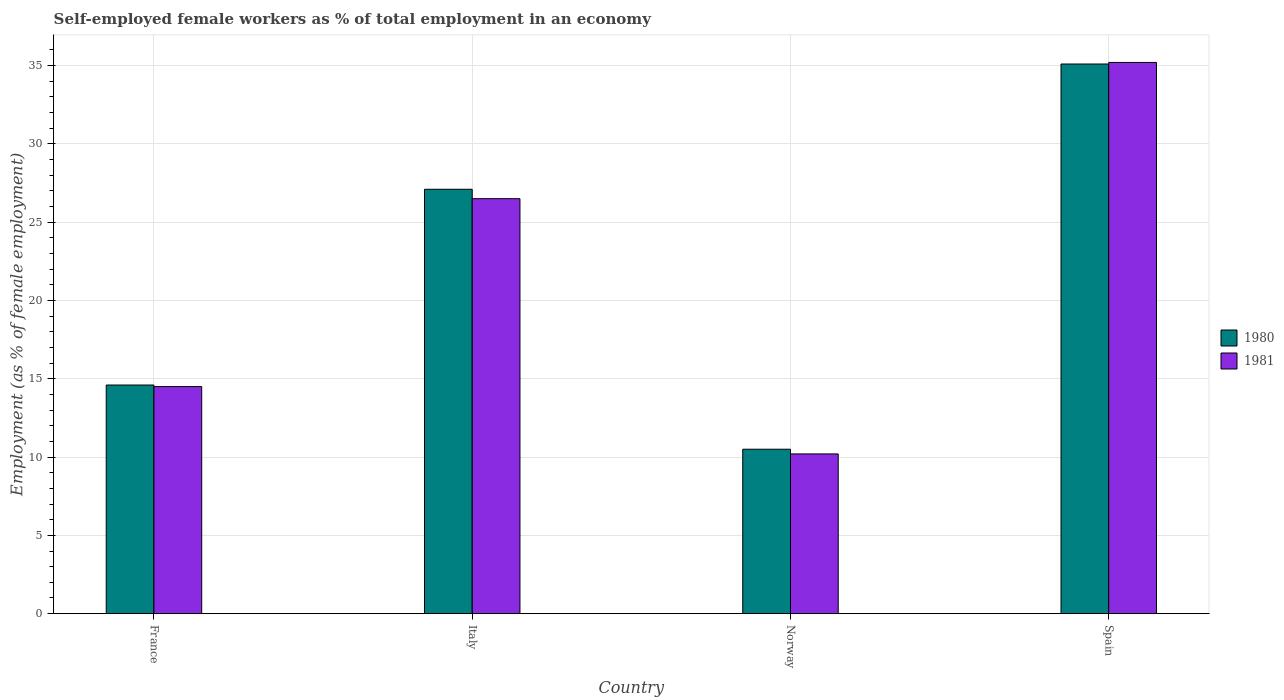How many different coloured bars are there?
Give a very brief answer. 2. Are the number of bars per tick equal to the number of legend labels?
Provide a short and direct response. Yes. How many bars are there on the 3rd tick from the left?
Make the answer very short. 2. How many bars are there on the 2nd tick from the right?
Provide a short and direct response. 2. Across all countries, what is the maximum percentage of self-employed female workers in 1980?
Make the answer very short. 35.1. Across all countries, what is the minimum percentage of self-employed female workers in 1981?
Provide a succinct answer. 10.2. What is the total percentage of self-employed female workers in 1981 in the graph?
Give a very brief answer. 86.4. What is the difference between the percentage of self-employed female workers in 1981 in France and that in Norway?
Your answer should be compact. 4.3. What is the difference between the percentage of self-employed female workers in 1981 in France and the percentage of self-employed female workers in 1980 in Italy?
Make the answer very short. -12.6. What is the average percentage of self-employed female workers in 1981 per country?
Provide a short and direct response. 21.6. What is the difference between the percentage of self-employed female workers of/in 1980 and percentage of self-employed female workers of/in 1981 in France?
Provide a succinct answer. 0.1. What is the ratio of the percentage of self-employed female workers in 1980 in France to that in Spain?
Ensure brevity in your answer.  0.42. What is the difference between the highest and the second highest percentage of self-employed female workers in 1981?
Your answer should be very brief. -8.7. What is the difference between the highest and the lowest percentage of self-employed female workers in 1981?
Offer a terse response. 25. Are the values on the major ticks of Y-axis written in scientific E-notation?
Keep it short and to the point. No. Does the graph contain any zero values?
Your answer should be compact. No. Where does the legend appear in the graph?
Your response must be concise. Center right. How many legend labels are there?
Ensure brevity in your answer.  2. How are the legend labels stacked?
Offer a very short reply. Vertical. What is the title of the graph?
Give a very brief answer. Self-employed female workers as % of total employment in an economy. What is the label or title of the Y-axis?
Keep it short and to the point. Employment (as % of female employment). What is the Employment (as % of female employment) of 1980 in France?
Offer a terse response. 14.6. What is the Employment (as % of female employment) in 1981 in France?
Your answer should be very brief. 14.5. What is the Employment (as % of female employment) of 1980 in Italy?
Make the answer very short. 27.1. What is the Employment (as % of female employment) in 1981 in Norway?
Provide a short and direct response. 10.2. What is the Employment (as % of female employment) in 1980 in Spain?
Your answer should be compact. 35.1. What is the Employment (as % of female employment) of 1981 in Spain?
Ensure brevity in your answer.  35.2. Across all countries, what is the maximum Employment (as % of female employment) of 1980?
Your answer should be very brief. 35.1. Across all countries, what is the maximum Employment (as % of female employment) of 1981?
Provide a short and direct response. 35.2. Across all countries, what is the minimum Employment (as % of female employment) of 1981?
Provide a succinct answer. 10.2. What is the total Employment (as % of female employment) in 1980 in the graph?
Your response must be concise. 87.3. What is the total Employment (as % of female employment) in 1981 in the graph?
Your answer should be very brief. 86.4. What is the difference between the Employment (as % of female employment) in 1980 in France and that in Italy?
Your answer should be compact. -12.5. What is the difference between the Employment (as % of female employment) of 1980 in France and that in Spain?
Ensure brevity in your answer.  -20.5. What is the difference between the Employment (as % of female employment) of 1981 in France and that in Spain?
Your answer should be very brief. -20.7. What is the difference between the Employment (as % of female employment) of 1980 in Italy and that in Norway?
Your answer should be compact. 16.6. What is the difference between the Employment (as % of female employment) in 1981 in Italy and that in Norway?
Give a very brief answer. 16.3. What is the difference between the Employment (as % of female employment) of 1981 in Italy and that in Spain?
Your answer should be very brief. -8.7. What is the difference between the Employment (as % of female employment) of 1980 in Norway and that in Spain?
Make the answer very short. -24.6. What is the difference between the Employment (as % of female employment) in 1980 in France and the Employment (as % of female employment) in 1981 in Italy?
Offer a terse response. -11.9. What is the difference between the Employment (as % of female employment) of 1980 in France and the Employment (as % of female employment) of 1981 in Spain?
Keep it short and to the point. -20.6. What is the difference between the Employment (as % of female employment) of 1980 in Italy and the Employment (as % of female employment) of 1981 in Spain?
Your response must be concise. -8.1. What is the difference between the Employment (as % of female employment) in 1980 in Norway and the Employment (as % of female employment) in 1981 in Spain?
Ensure brevity in your answer.  -24.7. What is the average Employment (as % of female employment) of 1980 per country?
Give a very brief answer. 21.82. What is the average Employment (as % of female employment) of 1981 per country?
Keep it short and to the point. 21.6. What is the ratio of the Employment (as % of female employment) in 1980 in France to that in Italy?
Your response must be concise. 0.54. What is the ratio of the Employment (as % of female employment) in 1981 in France to that in Italy?
Provide a short and direct response. 0.55. What is the ratio of the Employment (as % of female employment) in 1980 in France to that in Norway?
Offer a very short reply. 1.39. What is the ratio of the Employment (as % of female employment) in 1981 in France to that in Norway?
Your answer should be very brief. 1.42. What is the ratio of the Employment (as % of female employment) of 1980 in France to that in Spain?
Your answer should be compact. 0.42. What is the ratio of the Employment (as % of female employment) in 1981 in France to that in Spain?
Give a very brief answer. 0.41. What is the ratio of the Employment (as % of female employment) of 1980 in Italy to that in Norway?
Provide a succinct answer. 2.58. What is the ratio of the Employment (as % of female employment) in 1981 in Italy to that in Norway?
Make the answer very short. 2.6. What is the ratio of the Employment (as % of female employment) of 1980 in Italy to that in Spain?
Provide a succinct answer. 0.77. What is the ratio of the Employment (as % of female employment) in 1981 in Italy to that in Spain?
Keep it short and to the point. 0.75. What is the ratio of the Employment (as % of female employment) in 1980 in Norway to that in Spain?
Offer a terse response. 0.3. What is the ratio of the Employment (as % of female employment) of 1981 in Norway to that in Spain?
Your response must be concise. 0.29. What is the difference between the highest and the second highest Employment (as % of female employment) in 1980?
Offer a very short reply. 8. What is the difference between the highest and the lowest Employment (as % of female employment) in 1980?
Make the answer very short. 24.6. What is the difference between the highest and the lowest Employment (as % of female employment) of 1981?
Offer a very short reply. 25. 